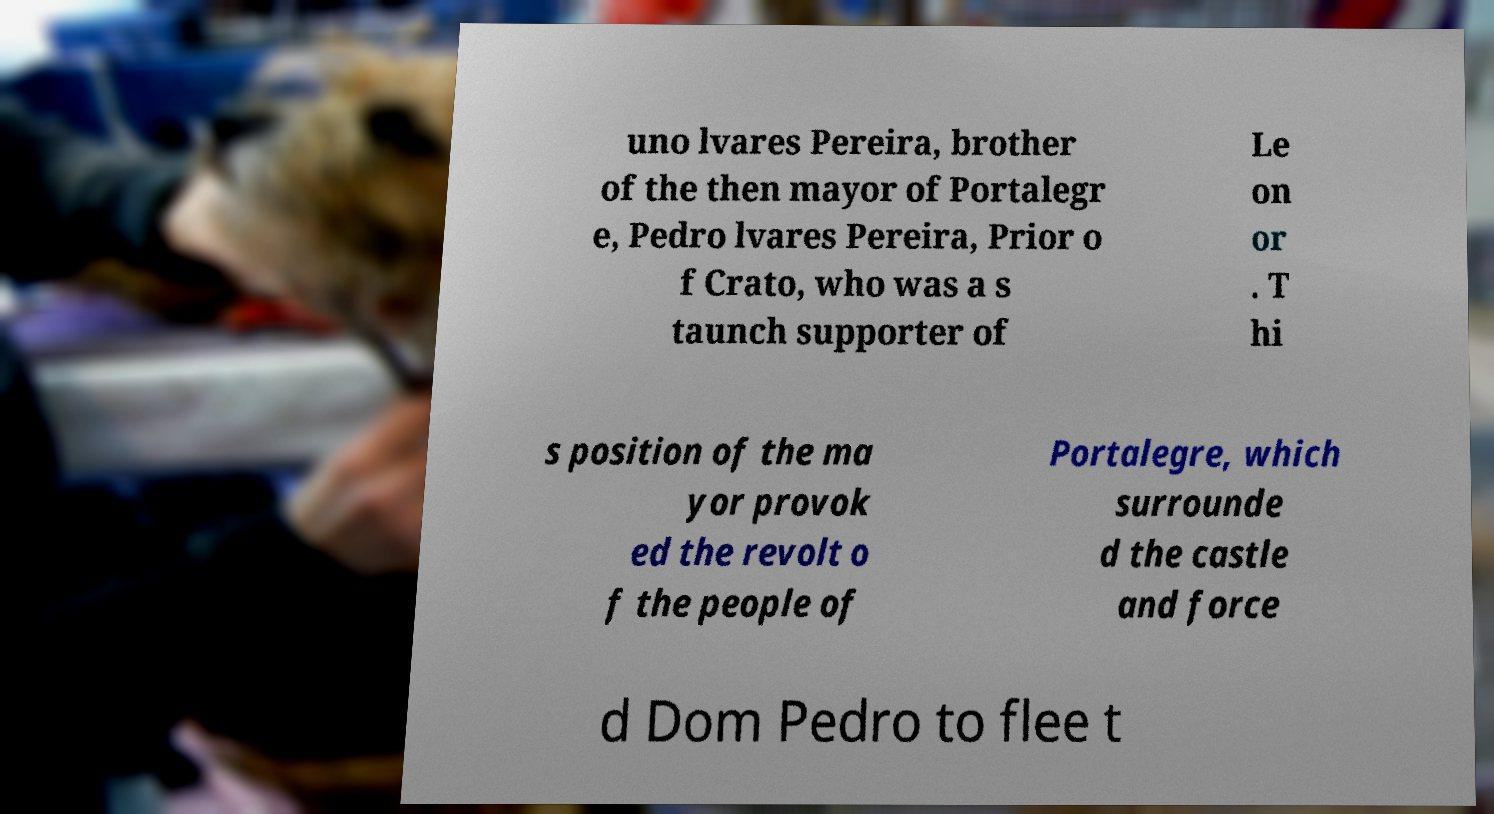Please identify and transcribe the text found in this image. uno lvares Pereira, brother of the then mayor of Portalegr e, Pedro lvares Pereira, Prior o f Crato, who was a s taunch supporter of Le on or . T hi s position of the ma yor provok ed the revolt o f the people of Portalegre, which surrounde d the castle and force d Dom Pedro to flee t 